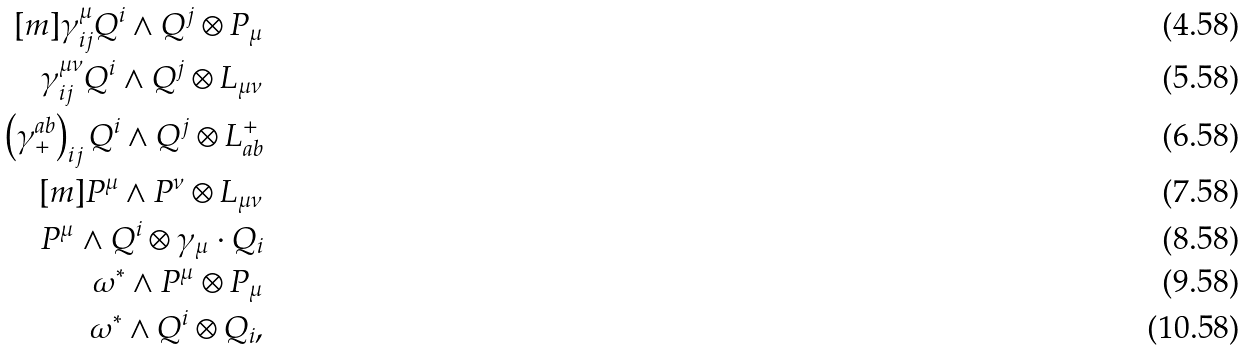Convert formula to latex. <formula><loc_0><loc_0><loc_500><loc_500>[ m ] \gamma ^ { \mu } _ { i j } Q ^ { i } \wedge Q ^ { j } \otimes P _ { \mu } \\ \gamma ^ { \mu \nu } _ { i j } Q ^ { i } \wedge Q ^ { j } \otimes L _ { \mu \nu } \\ \left ( \gamma ^ { a b } _ { + } \right ) _ { i j } Q ^ { i } \wedge Q ^ { j } \otimes L _ { a b } ^ { + } \\ \quad [ m ] P ^ { \mu } \wedge P ^ { \nu } \otimes L _ { \mu \nu } \\ P ^ { \mu } \wedge Q ^ { i } \otimes \gamma _ { \mu } \cdot Q _ { i } \\ \omega ^ { * } \wedge P ^ { \mu } \otimes P _ { \mu } \\ \omega ^ { * } \wedge Q ^ { i } \otimes Q _ { i } ,</formula> 